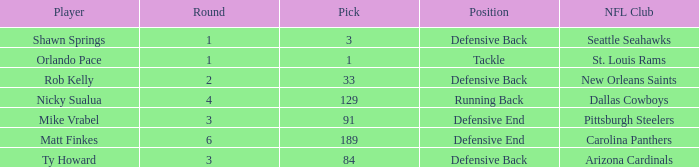What is the lowest pick that has arizona cardinals as the NFL club? 84.0. 